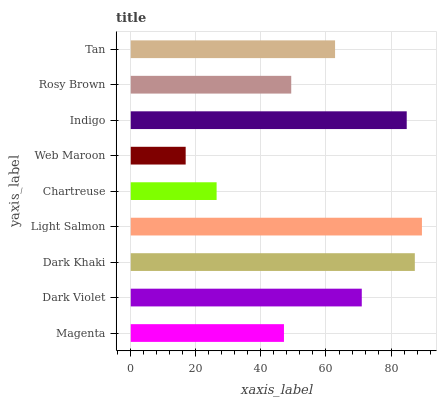Is Web Maroon the minimum?
Answer yes or no. Yes. Is Light Salmon the maximum?
Answer yes or no. Yes. Is Dark Violet the minimum?
Answer yes or no. No. Is Dark Violet the maximum?
Answer yes or no. No. Is Dark Violet greater than Magenta?
Answer yes or no. Yes. Is Magenta less than Dark Violet?
Answer yes or no. Yes. Is Magenta greater than Dark Violet?
Answer yes or no. No. Is Dark Violet less than Magenta?
Answer yes or no. No. Is Tan the high median?
Answer yes or no. Yes. Is Tan the low median?
Answer yes or no. Yes. Is Chartreuse the high median?
Answer yes or no. No. Is Chartreuse the low median?
Answer yes or no. No. 